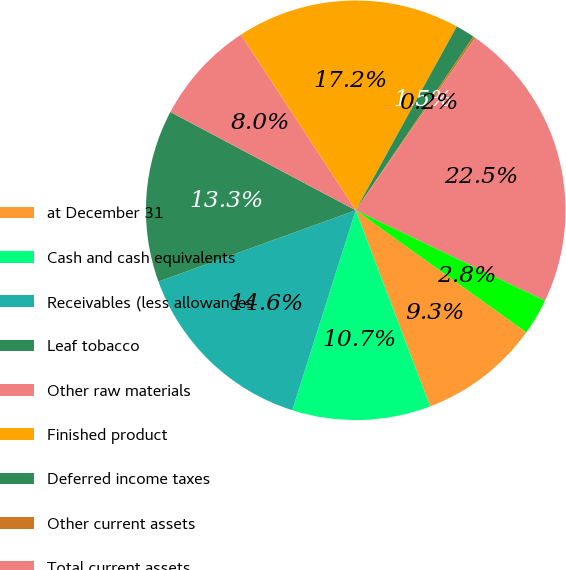<chart> <loc_0><loc_0><loc_500><loc_500><pie_chart><fcel>at December 31<fcel>Cash and cash equivalents<fcel>Receivables (less allowances<fcel>Leaf tobacco<fcel>Other raw materials<fcel>Finished product<fcel>Deferred income taxes<fcel>Other current assets<fcel>Total current assets<fcel>Land and land improvements<nl><fcel>9.34%<fcel>10.66%<fcel>14.59%<fcel>13.28%<fcel>8.03%<fcel>17.21%<fcel>1.48%<fcel>0.17%<fcel>22.45%<fcel>2.79%<nl></chart> 